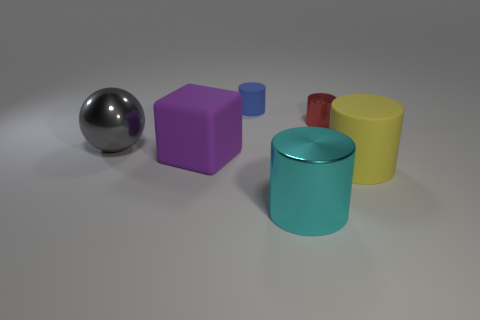Subtract all gray cylinders. Subtract all blue balls. How many cylinders are left? 4 Add 3 tiny green rubber blocks. How many objects exist? 9 Subtract all spheres. How many objects are left? 5 Subtract all tiny green rubber blocks. Subtract all shiny cylinders. How many objects are left? 4 Add 1 big things. How many big things are left? 5 Add 2 purple rubber blocks. How many purple rubber blocks exist? 3 Subtract 0 yellow balls. How many objects are left? 6 